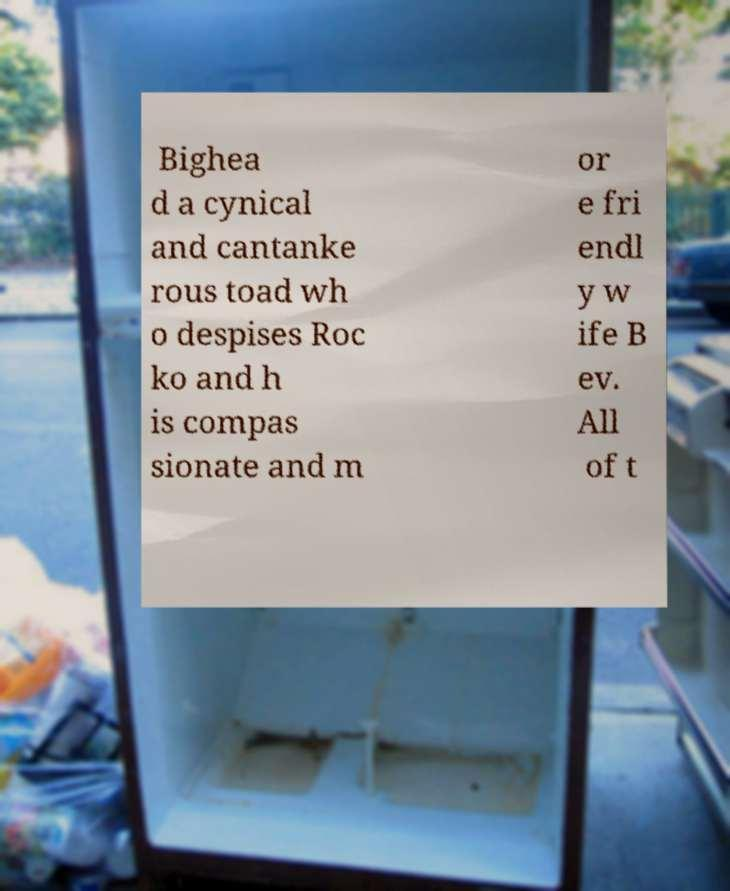Please identify and transcribe the text found in this image. Bighea d a cynical and cantanke rous toad wh o despises Roc ko and h is compas sionate and m or e fri endl y w ife B ev. All of t 